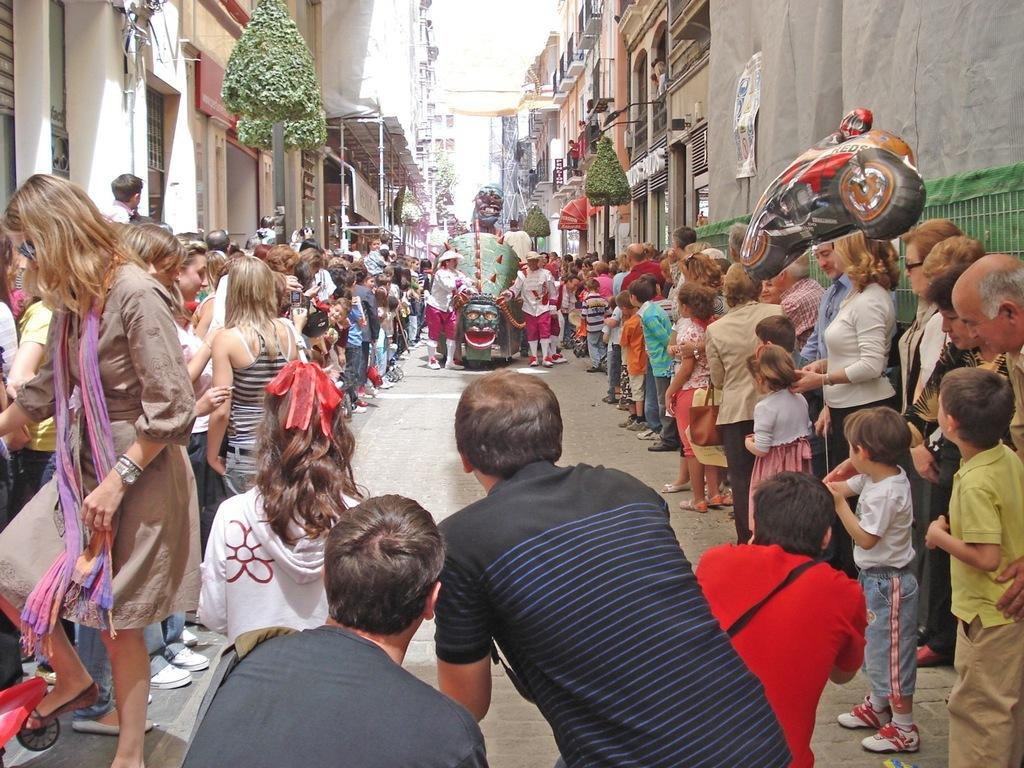What is happening in the center of the image? There are people standing in the middle of the image. What can be seen in the distance behind the people? There are buildings and plants visible in the background. What type of beam is being used to increase the height of the plants in the image? There is no beam or action to increase the height of the plants in the image; they are simply visible in the background. 